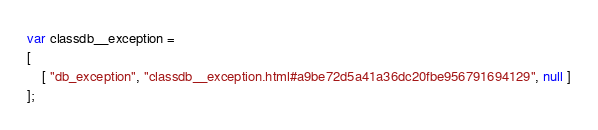<code> <loc_0><loc_0><loc_500><loc_500><_JavaScript_>var classdb__exception =
[
    [ "db_exception", "classdb__exception.html#a9be72d5a41a36dc20fbe956791694129", null ]
];</code> 